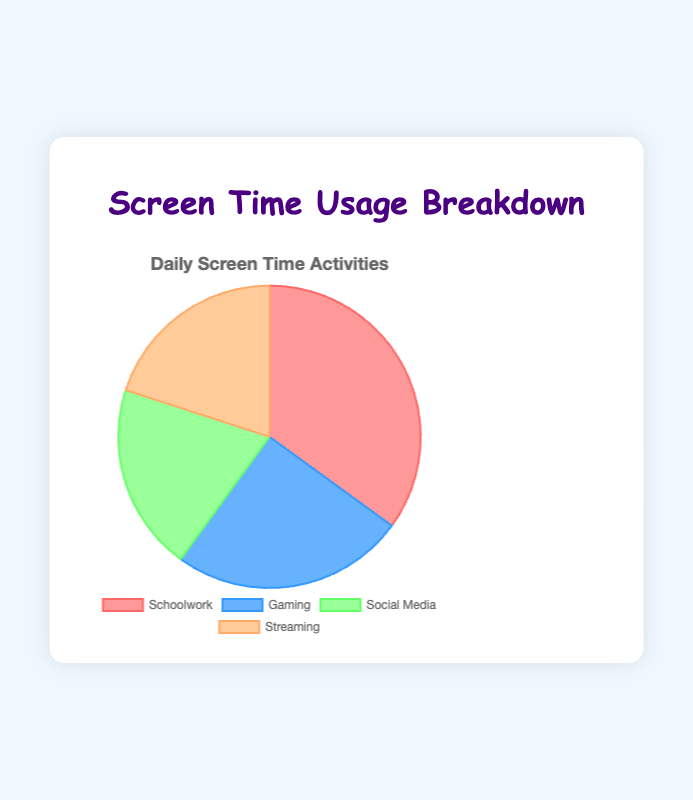What percentage of screen time is spent on activities other than schoolwork? To find the percentage of screen time spent on activities other than schoolwork, subtract the percentage of screen time spent on schoolwork (35%) from the total screen time (100%). That gives 100% - 35% = 65%.
Answer: 65% Which activities have equal screen time usage? The activities 'Social Media' and 'Streaming' both have the same percentage of screen time usage, which is 20%.
Answer: Social Media and Streaming How much more screen time is spent on gaming than on social media? The percentage of screen time spent on gaming is 25%, and on social media, it is 20%. The difference between them is 25% - 20% = 5%.
Answer: 5% What is the percentage difference between the highest and lowest screen time usage activities? The highest percentage of screen time usage is for schoolwork at 35%, and the lowest is for social media and streaming at 20%. The difference is 35% - 20% = 15%.
Answer: 15% What are the two dominant colors used in the chart? Visually, the largest segment which represents schoolwork is in light red (pinkish), and the second largest segment representing gaming is in light blue.
Answer: Light red and light blue What is the mean percentage of screen time usage for all activities? To calculate the mean, add up all the percentages and divide by the number of activities: (35% + 25% + 20% + 20%) / 4 = 25%.
Answer: 25% Which activity has the second highest screen time usage? The activity with the second highest screen time usage is gaming at 25%.
Answer: Gaming How are the screen time usages split between educational (schoolwork) and non-educational activities (gaming, social media, streaming)? The percentage for schoolwork is 35%. For non-educational activities, sum the percentages of gaming, social media, and streaming: 25% + 20% + 20% = 65%.
Answer: 35% educational, 65% non-educational Which section of the pie chart is colored light green and what percentage does it represent? The light green section represents Social Media and it accounts for 20% of the screen time usage.
Answer: Social Media, 20% If streaming time were to increase by 5% and schoolwork time decrease by 5%, what would be the new percentages for each? Initially, streaming is at 20% and schoolwork at 35%. After increases and decreases: streaming will be 25% and schoolwork will be 30%.
Answer: Streaming 25%, Schoolwork 30% 